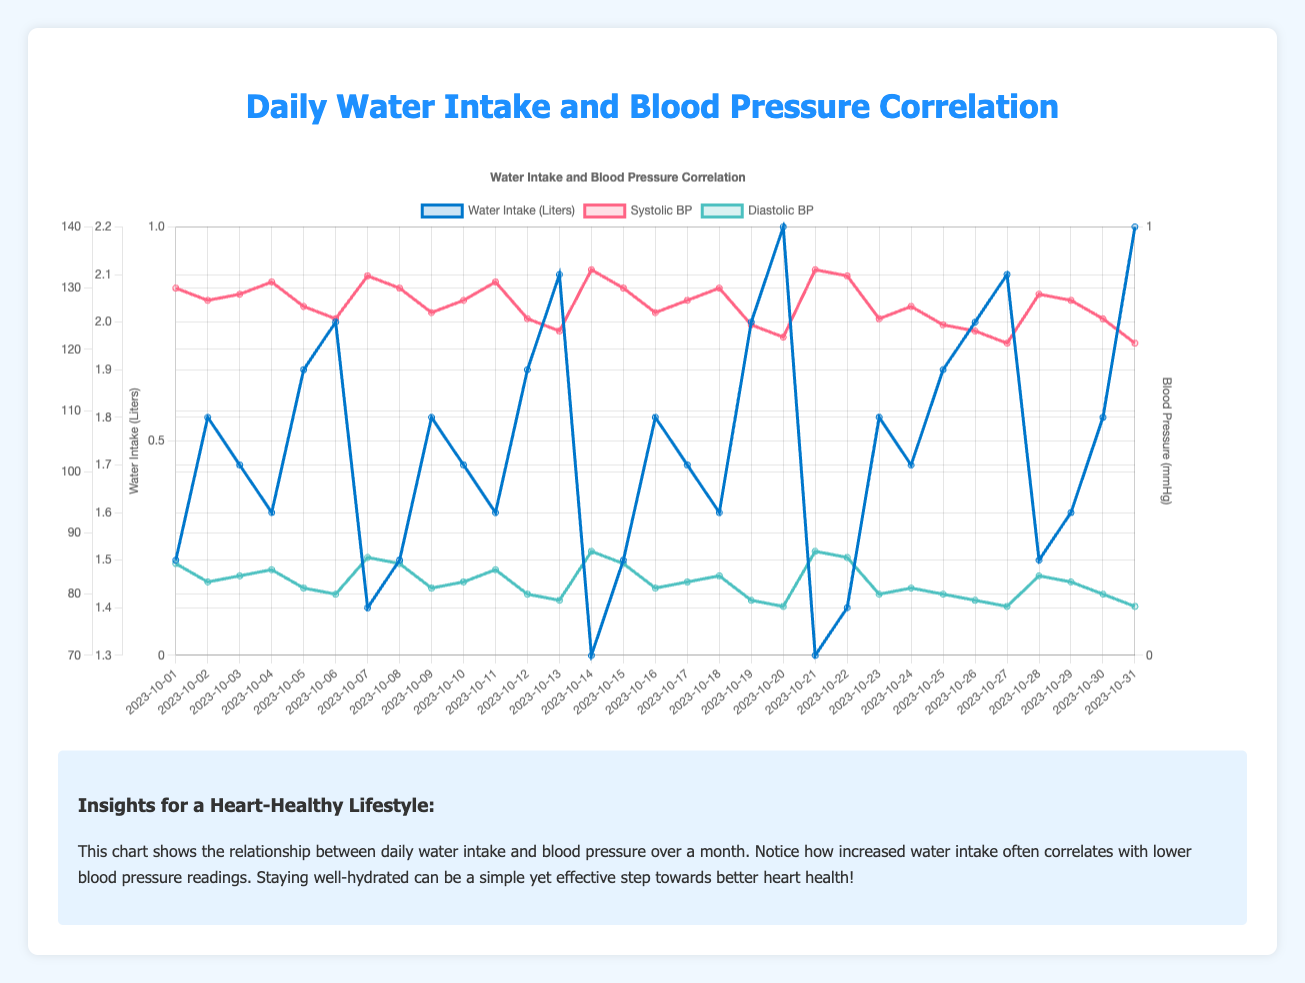What is the average daily water intake for the month? To find the average daily water intake, sum all the water intake values and then divide by the number of days in the month. The total water intake is 52.2 liters over 31 days, so the average is 52.2 / 31.
Answer: 1.68 liters When did the systolic blood pressure drop below 125 mmHg for the first time? Look at the 'Systolic BP' data across the days and identify the first instance when the value is less than 125 mmHg. On October 13th, the systolic BP was 123 mmHg, which is the first occurrence below 125 mmHg.
Answer: October 13 Which day had the highest diastolic blood pressure, and what was it? Check the diastolic blood pressure values and find the maximum. The highest diastolic BP is 87 mmHg, which occurred on October 14 and October 21.
Answer: October 14 and October 21, 87 mmHg What is the difference in systolic blood pressure on October 13 and October 27? Compare the systolic BP values on these two days. On October 13, the systolic BP was 123 mmHg, and on October 27, it was 121 mmHg. The difference is 123 - 121.
Answer: 2 mmHg On which days did the water intake exceed 2.0 liters, and what were the corresponding systolic blood pressures? Identify days with water intake greater than 2.0 liters. On October 13, 20, 27, and 31, the water intake exceeded 2.0 liters, with systolic BP values of 123, 122, 121, and 121 mmHg respectively.
Answer: October 13 (123 mmHg), October 20 (122 mmHg), October 27 (121 mmHg), October 31 (121 mmHg) What is the median diastolic blood pressure for the month? First, order the diastolic BP values. For 31 values, the median is the 16th value when sorted in ascending order. The ordered values lead to a median of 81 mmHg.
Answer: 81 mmHg How do the systolic and diastolic blood pressures compare on days with the lowest water intake? Identify the days with the lowest water intake, which are October 14 and October 21, both with 1.3 liters. The systolic and diastolic BP values on these days are 133/87 mmHg for both days.
Answer: 133/87 mmHg on October 14 and October 21 What trends can you observe in blood pressure if the water intake increases steadily? Analyze the data points where the water intake increases noticeably and observe the trend in blood pressure. Generally, as water intake increases, both systolic and diastolic BP tend to decrease, e.g., from October 13 to 20.
Answer: Decreasing blood pressure with increased water intake What is the correlation between water intake and diastolic blood pressure? Visually inspect the chart for the overall pattern between water intake and diastolic BP. Typically, higher water intake is associated with lower diastolic BP values, indicating a negative correlation.
Answer: Negative correlation 